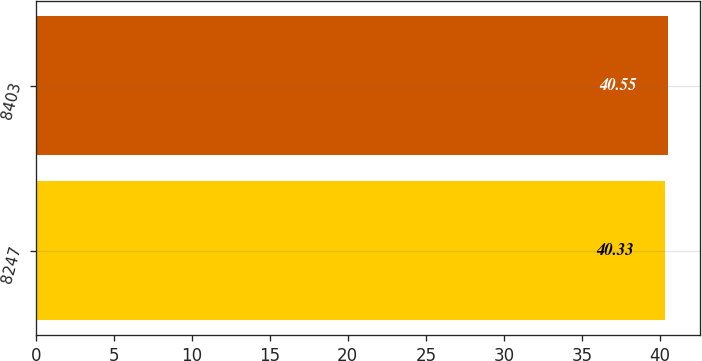<chart> <loc_0><loc_0><loc_500><loc_500><bar_chart><fcel>8247<fcel>8403<nl><fcel>40.33<fcel>40.55<nl></chart> 